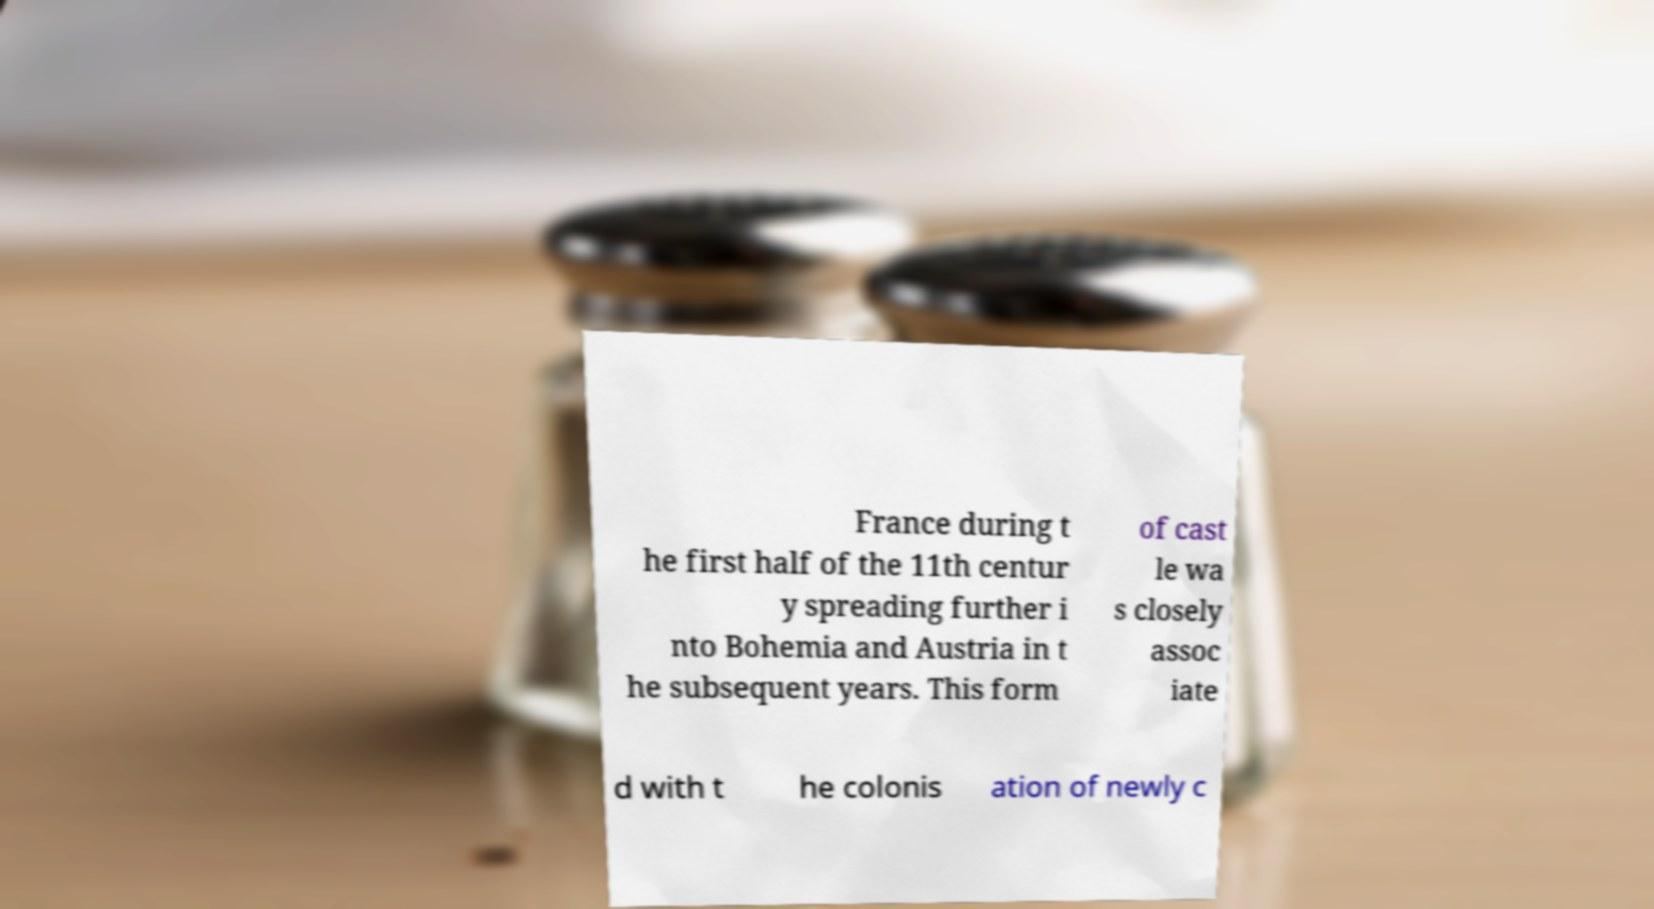Can you accurately transcribe the text from the provided image for me? France during t he first half of the 11th centur y spreading further i nto Bohemia and Austria in t he subsequent years. This form of cast le wa s closely assoc iate d with t he colonis ation of newly c 